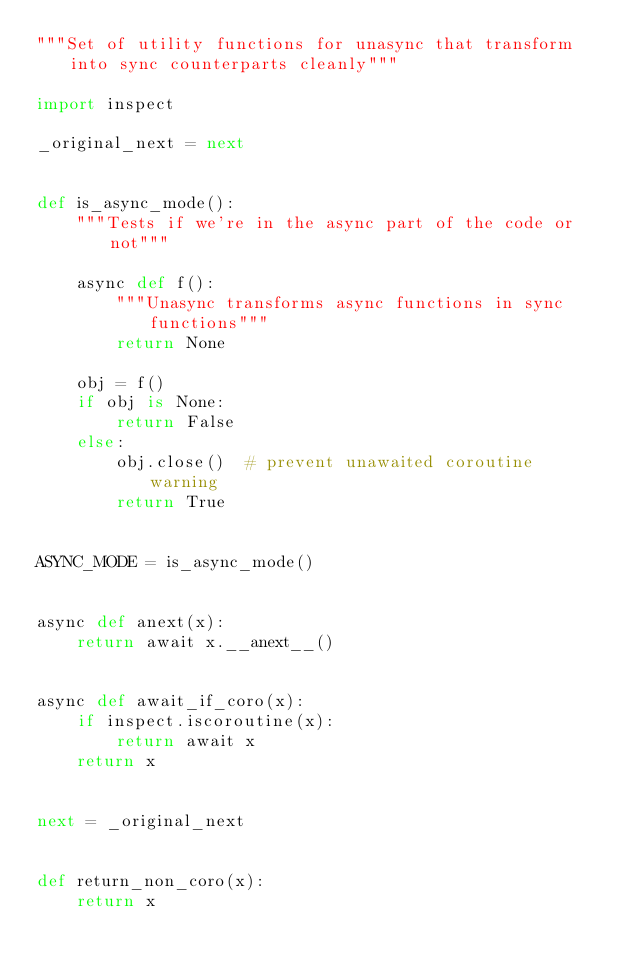<code> <loc_0><loc_0><loc_500><loc_500><_Python_>"""Set of utility functions for unasync that transform into sync counterparts cleanly"""

import inspect

_original_next = next


def is_async_mode():
    """Tests if we're in the async part of the code or not"""

    async def f():
        """Unasync transforms async functions in sync functions"""
        return None

    obj = f()
    if obj is None:
        return False
    else:
        obj.close()  # prevent unawaited coroutine warning
        return True


ASYNC_MODE = is_async_mode()


async def anext(x):
    return await x.__anext__()


async def await_if_coro(x):
    if inspect.iscoroutine(x):
        return await x
    return x


next = _original_next


def return_non_coro(x):
    return x
</code> 